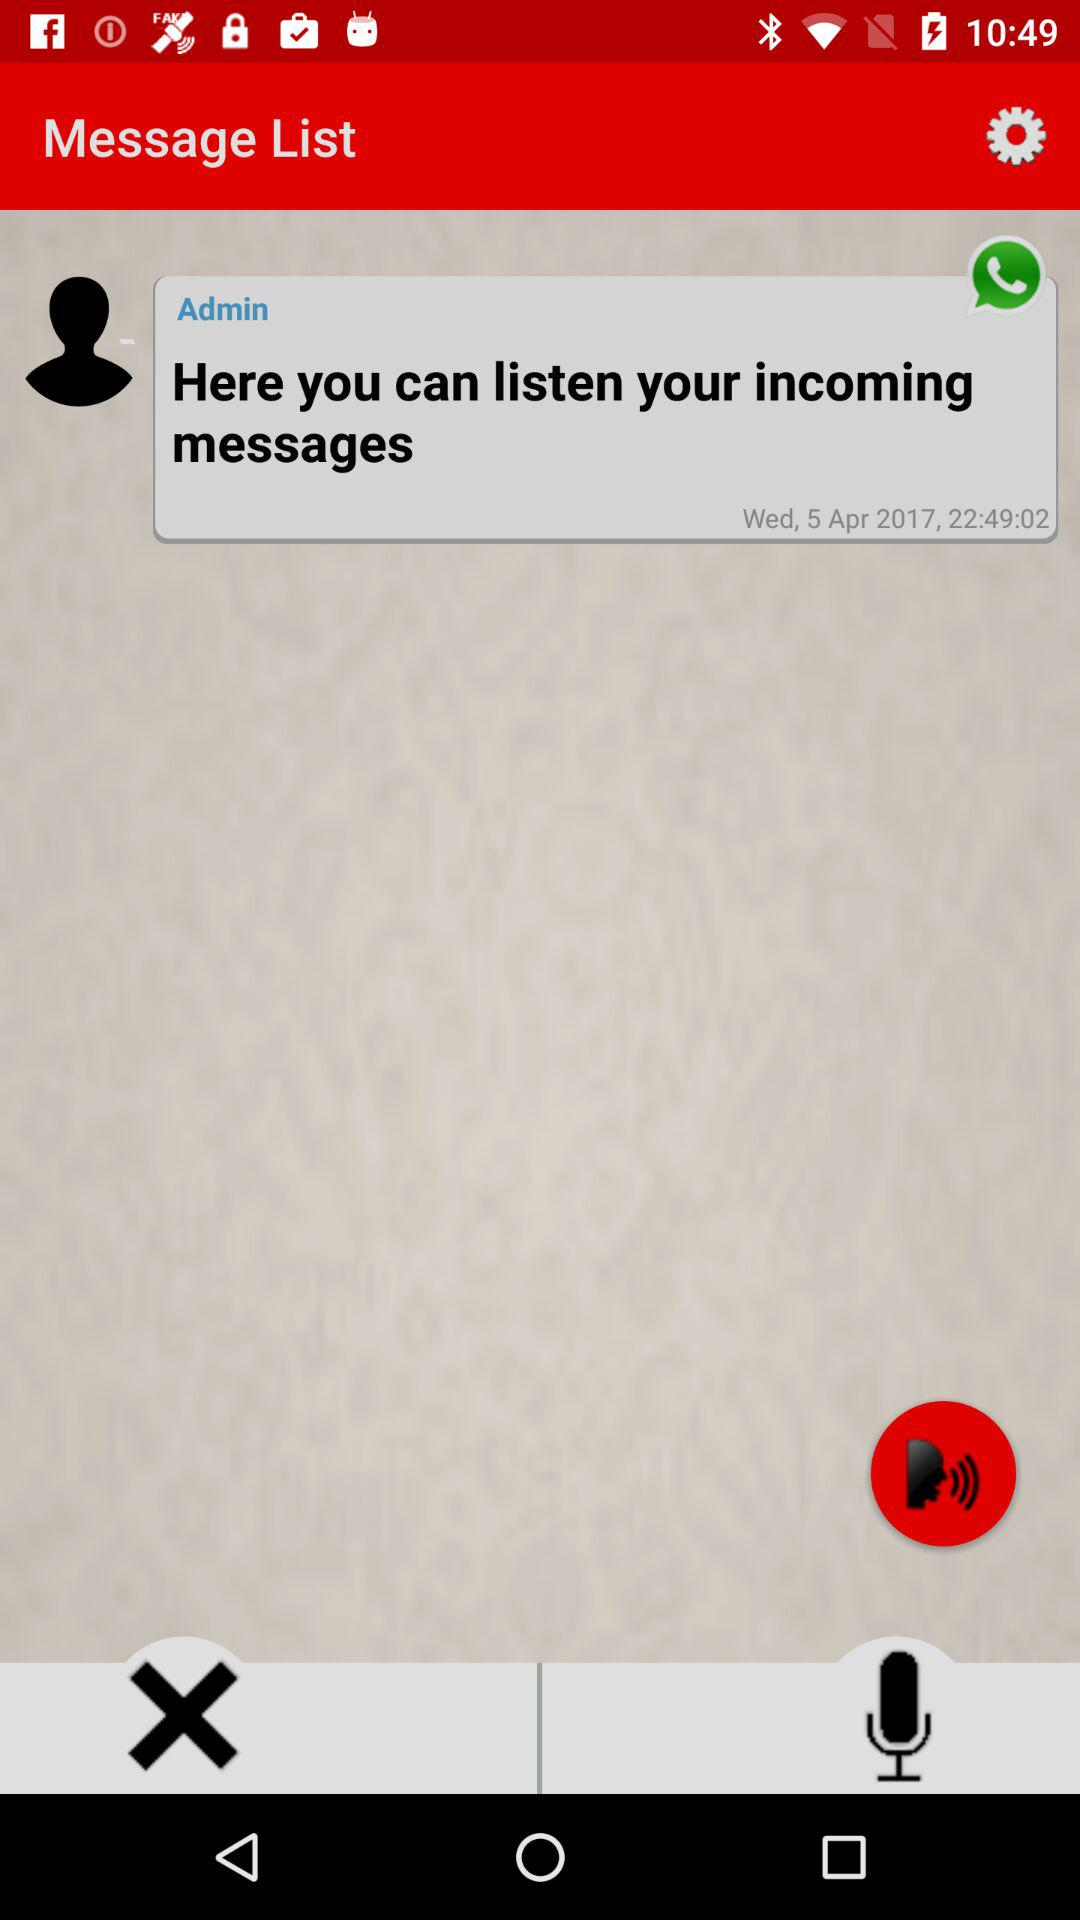What is the time of the message? The time of the message is 22 hours 49 minutes and 2 seconds. 